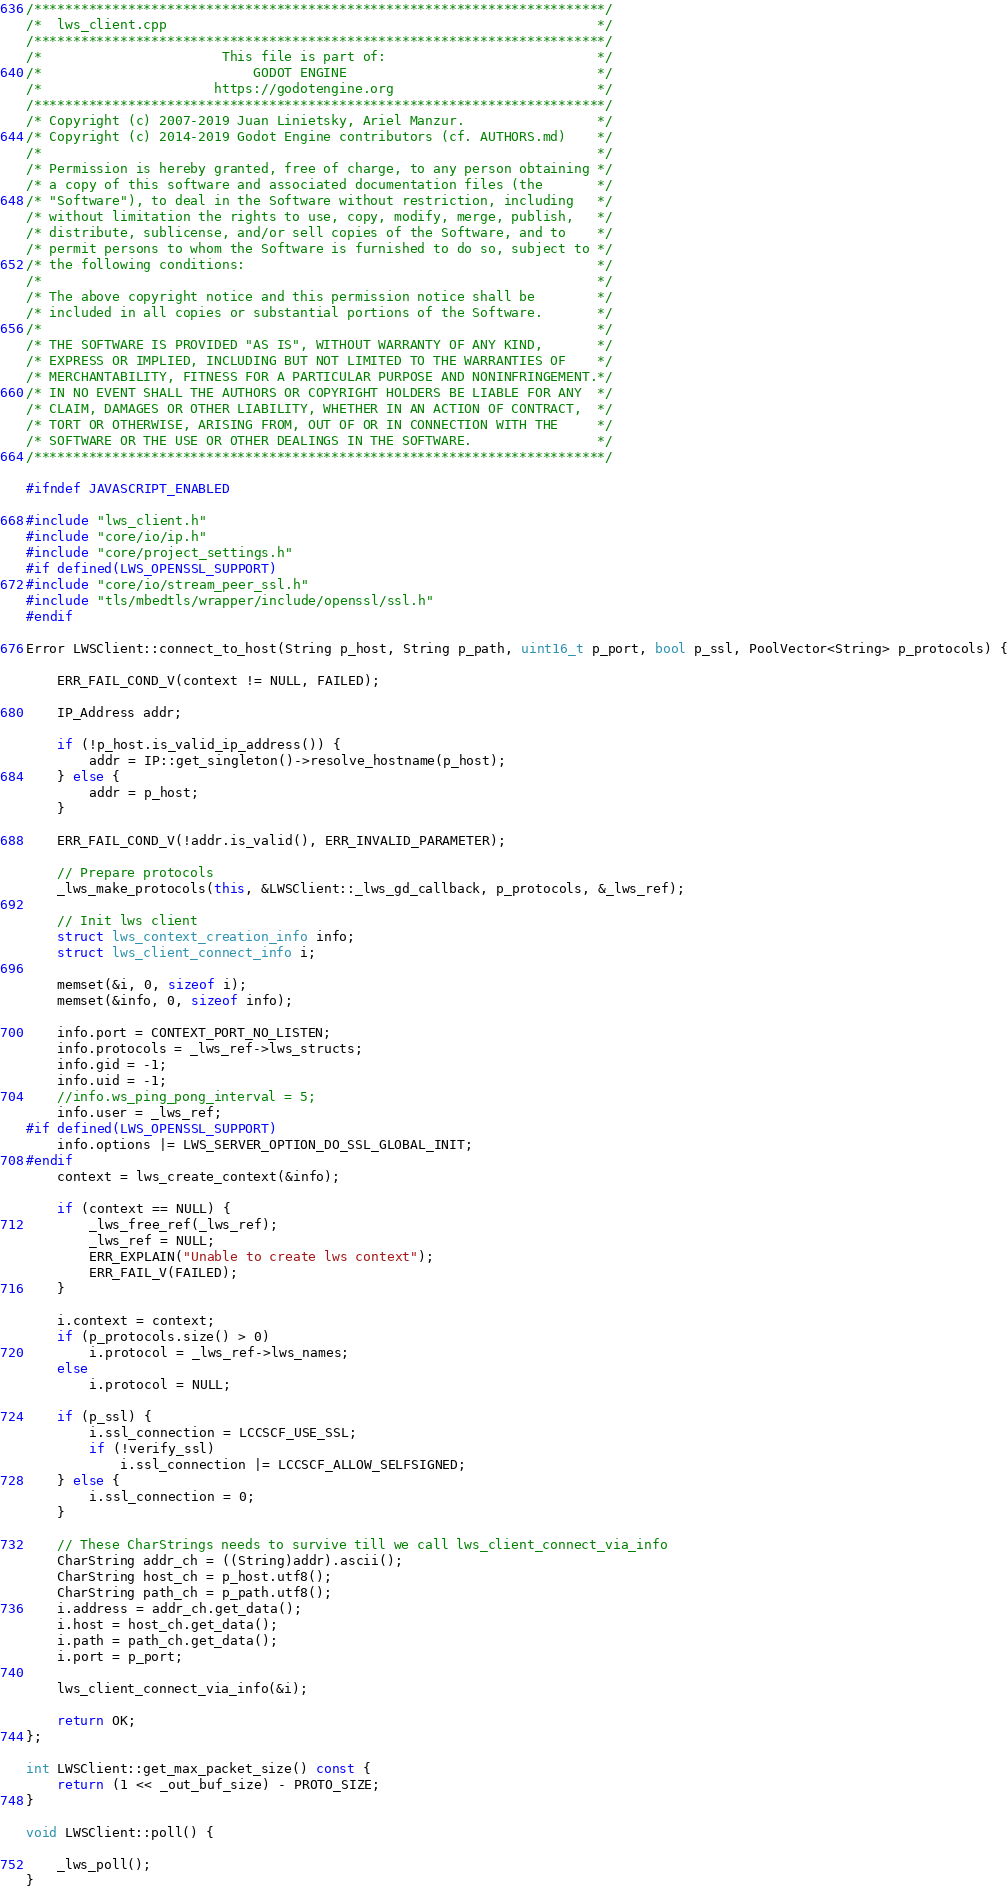Convert code to text. <code><loc_0><loc_0><loc_500><loc_500><_C++_>/*************************************************************************/
/*  lws_client.cpp                                                       */
/*************************************************************************/
/*                       This file is part of:                           */
/*                           GODOT ENGINE                                */
/*                      https://godotengine.org                          */
/*************************************************************************/
/* Copyright (c) 2007-2019 Juan Linietsky, Ariel Manzur.                 */
/* Copyright (c) 2014-2019 Godot Engine contributors (cf. AUTHORS.md)    */
/*                                                                       */
/* Permission is hereby granted, free of charge, to any person obtaining */
/* a copy of this software and associated documentation files (the       */
/* "Software"), to deal in the Software without restriction, including   */
/* without limitation the rights to use, copy, modify, merge, publish,   */
/* distribute, sublicense, and/or sell copies of the Software, and to    */
/* permit persons to whom the Software is furnished to do so, subject to */
/* the following conditions:                                             */
/*                                                                       */
/* The above copyright notice and this permission notice shall be        */
/* included in all copies or substantial portions of the Software.       */
/*                                                                       */
/* THE SOFTWARE IS PROVIDED "AS IS", WITHOUT WARRANTY OF ANY KIND,       */
/* EXPRESS OR IMPLIED, INCLUDING BUT NOT LIMITED TO THE WARRANTIES OF    */
/* MERCHANTABILITY, FITNESS FOR A PARTICULAR PURPOSE AND NONINFRINGEMENT.*/
/* IN NO EVENT SHALL THE AUTHORS OR COPYRIGHT HOLDERS BE LIABLE FOR ANY  */
/* CLAIM, DAMAGES OR OTHER LIABILITY, WHETHER IN AN ACTION OF CONTRACT,  */
/* TORT OR OTHERWISE, ARISING FROM, OUT OF OR IN CONNECTION WITH THE     */
/* SOFTWARE OR THE USE OR OTHER DEALINGS IN THE SOFTWARE.                */
/*************************************************************************/

#ifndef JAVASCRIPT_ENABLED

#include "lws_client.h"
#include "core/io/ip.h"
#include "core/project_settings.h"
#if defined(LWS_OPENSSL_SUPPORT)
#include "core/io/stream_peer_ssl.h"
#include "tls/mbedtls/wrapper/include/openssl/ssl.h"
#endif

Error LWSClient::connect_to_host(String p_host, String p_path, uint16_t p_port, bool p_ssl, PoolVector<String> p_protocols) {

	ERR_FAIL_COND_V(context != NULL, FAILED);

	IP_Address addr;

	if (!p_host.is_valid_ip_address()) {
		addr = IP::get_singleton()->resolve_hostname(p_host);
	} else {
		addr = p_host;
	}

	ERR_FAIL_COND_V(!addr.is_valid(), ERR_INVALID_PARAMETER);

	// Prepare protocols
	_lws_make_protocols(this, &LWSClient::_lws_gd_callback, p_protocols, &_lws_ref);

	// Init lws client
	struct lws_context_creation_info info;
	struct lws_client_connect_info i;

	memset(&i, 0, sizeof i);
	memset(&info, 0, sizeof info);

	info.port = CONTEXT_PORT_NO_LISTEN;
	info.protocols = _lws_ref->lws_structs;
	info.gid = -1;
	info.uid = -1;
	//info.ws_ping_pong_interval = 5;
	info.user = _lws_ref;
#if defined(LWS_OPENSSL_SUPPORT)
	info.options |= LWS_SERVER_OPTION_DO_SSL_GLOBAL_INIT;
#endif
	context = lws_create_context(&info);

	if (context == NULL) {
		_lws_free_ref(_lws_ref);
		_lws_ref = NULL;
		ERR_EXPLAIN("Unable to create lws context");
		ERR_FAIL_V(FAILED);
	}

	i.context = context;
	if (p_protocols.size() > 0)
		i.protocol = _lws_ref->lws_names;
	else
		i.protocol = NULL;

	if (p_ssl) {
		i.ssl_connection = LCCSCF_USE_SSL;
		if (!verify_ssl)
			i.ssl_connection |= LCCSCF_ALLOW_SELFSIGNED;
	} else {
		i.ssl_connection = 0;
	}

	// These CharStrings needs to survive till we call lws_client_connect_via_info
	CharString addr_ch = ((String)addr).ascii();
	CharString host_ch = p_host.utf8();
	CharString path_ch = p_path.utf8();
	i.address = addr_ch.get_data();
	i.host = host_ch.get_data();
	i.path = path_ch.get_data();
	i.port = p_port;

	lws_client_connect_via_info(&i);

	return OK;
};

int LWSClient::get_max_packet_size() const {
	return (1 << _out_buf_size) - PROTO_SIZE;
}

void LWSClient::poll() {

	_lws_poll();
}
</code> 